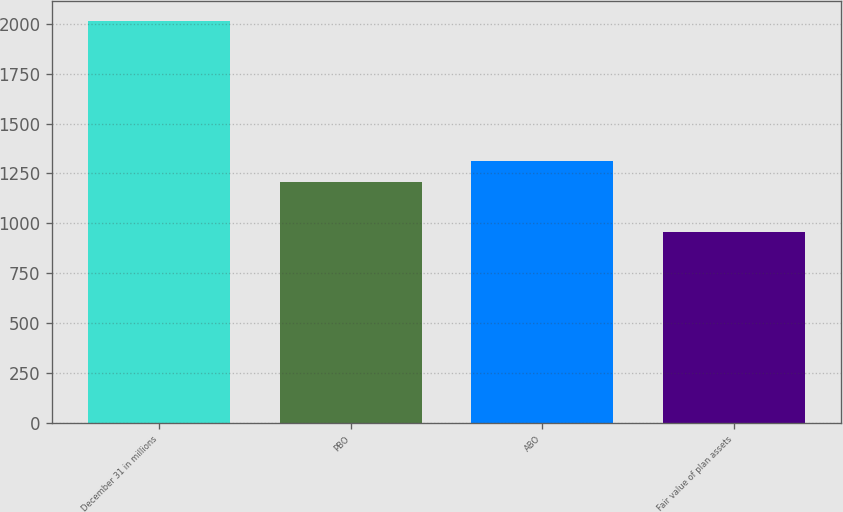<chart> <loc_0><loc_0><loc_500><loc_500><bar_chart><fcel>December 31 in millions<fcel>PBO<fcel>ABO<fcel>Fair value of plan assets<nl><fcel>2014<fcel>1206<fcel>1311.7<fcel>957<nl></chart> 